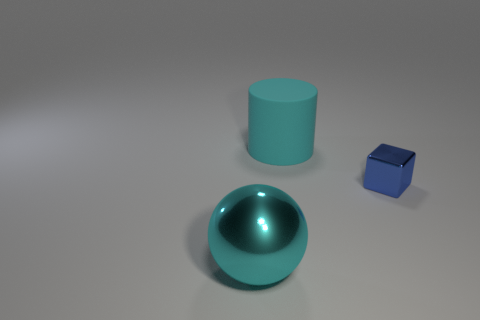Add 2 cyan cubes. How many objects exist? 5 Subtract all cylinders. How many objects are left? 2 Add 2 shiny cubes. How many shiny cubes exist? 3 Subtract 1 cyan balls. How many objects are left? 2 Subtract 1 balls. How many balls are left? 0 Subtract all big metal cubes. Subtract all big things. How many objects are left? 1 Add 3 large rubber cylinders. How many large rubber cylinders are left? 4 